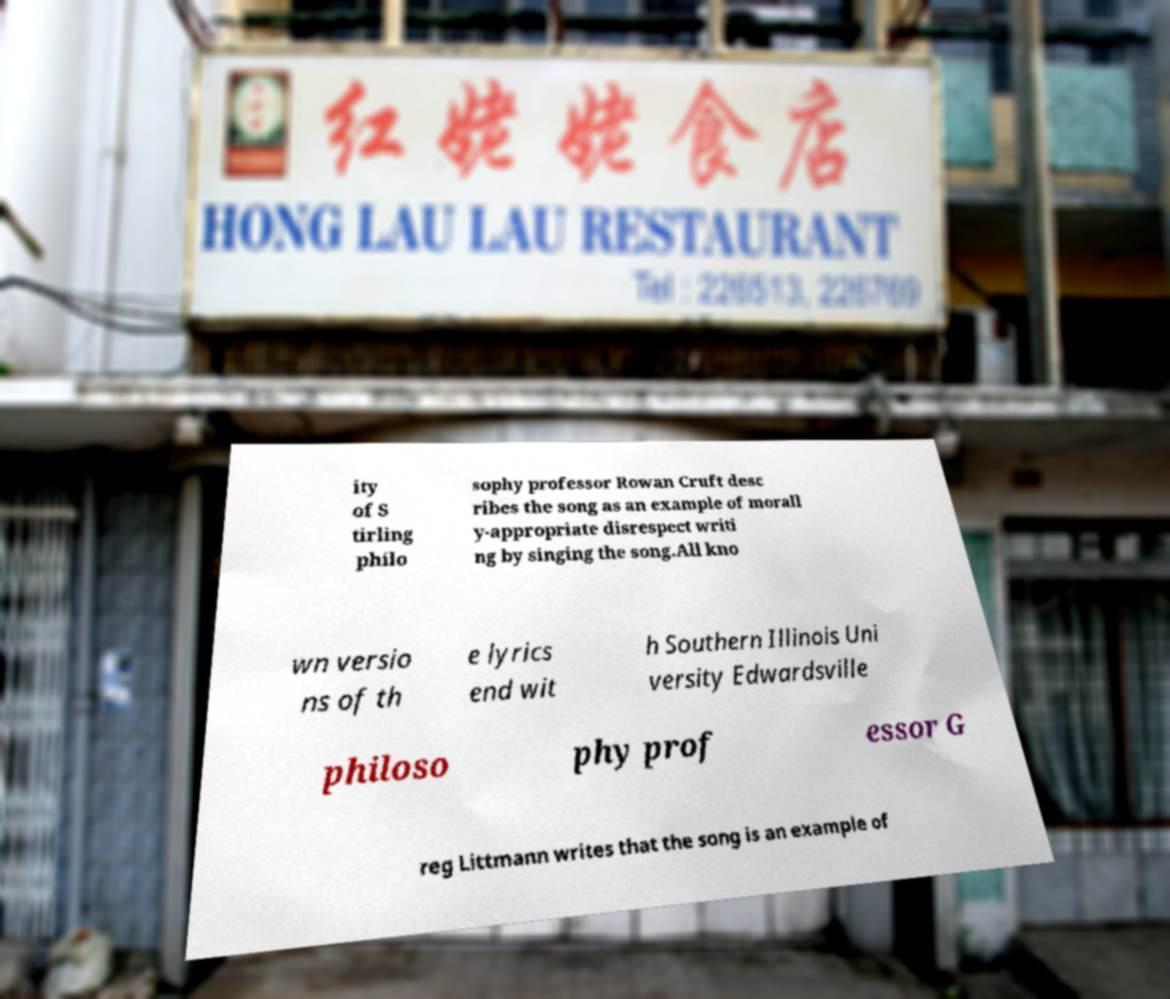Can you accurately transcribe the text from the provided image for me? ity of S tirling philo sophy professor Rowan Cruft desc ribes the song as an example of morall y-appropriate disrespect writi ng by singing the song.All kno wn versio ns of th e lyrics end wit h Southern Illinois Uni versity Edwardsville philoso phy prof essor G reg Littmann writes that the song is an example of 